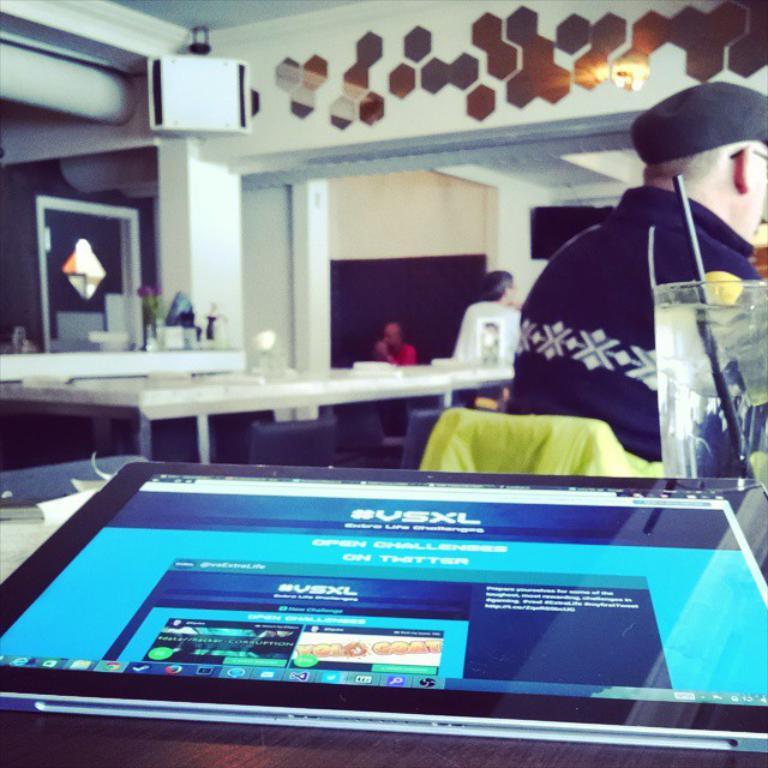How many people are sitting in the image? There are three persons sitting on chairs in the image. What is present in the image besides the people? There is a table, a tab, a glass, and a pillar at the back side of the image. What is the purpose of the tab on the table? The purpose of the tab on the tab on the table is not clear from the image, but it might be related to an order or payment. What is the glass used for? The glass might be used for drinking or holding a beverage. How many eggs are in the mailbox in the image? There is no mailbox or eggs present in the image. What type of passenger is sitting on the chair in the image? There is no indication of passengers in the image; the people are simply referred to as persons sitting on chairs. 